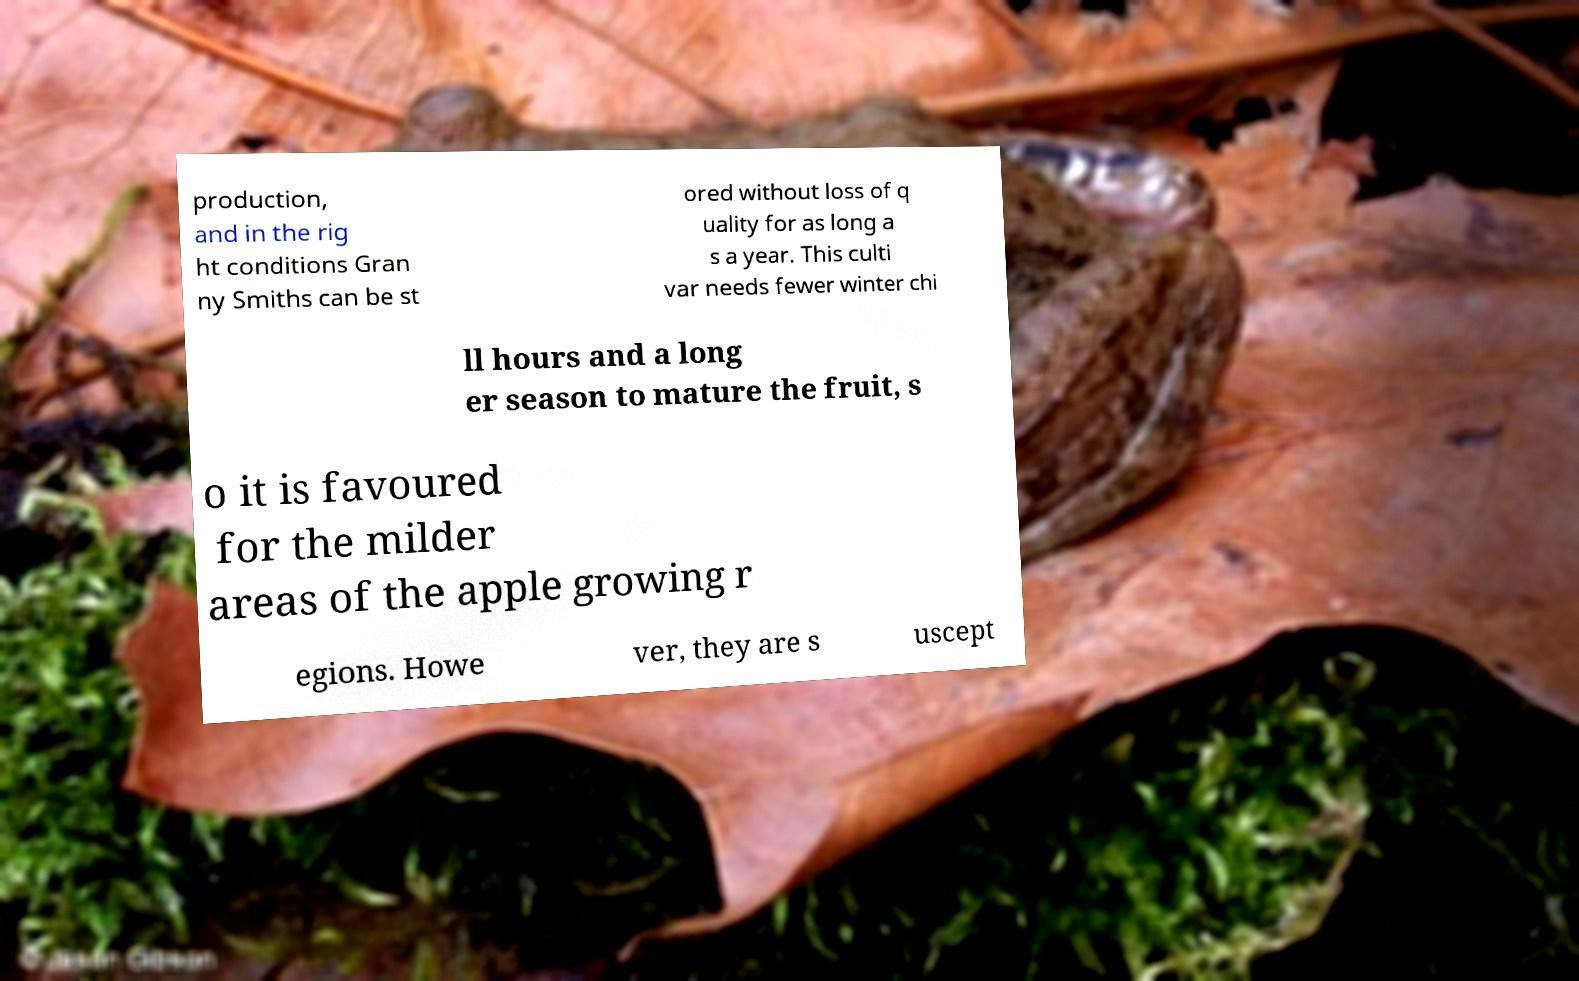What messages or text are displayed in this image? I need them in a readable, typed format. production, and in the rig ht conditions Gran ny Smiths can be st ored without loss of q uality for as long a s a year. This culti var needs fewer winter chi ll hours and a long er season to mature the fruit, s o it is favoured for the milder areas of the apple growing r egions. Howe ver, they are s uscept 